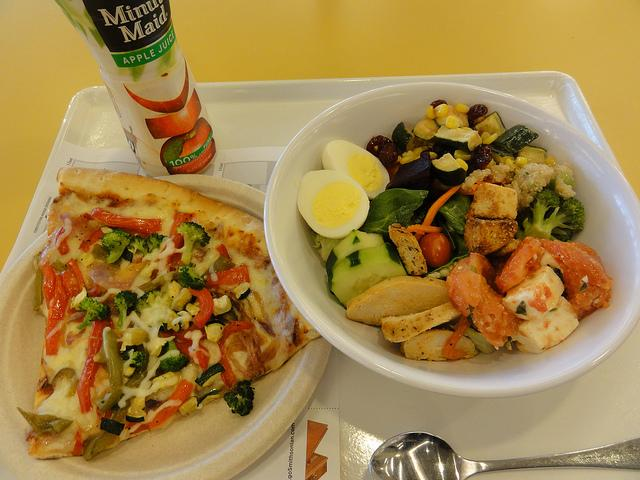What type of red sliced topping is on the pizza? Please explain your reasoning. pepper. The only sliced topping on the pizza which is red comes from a pepper. 